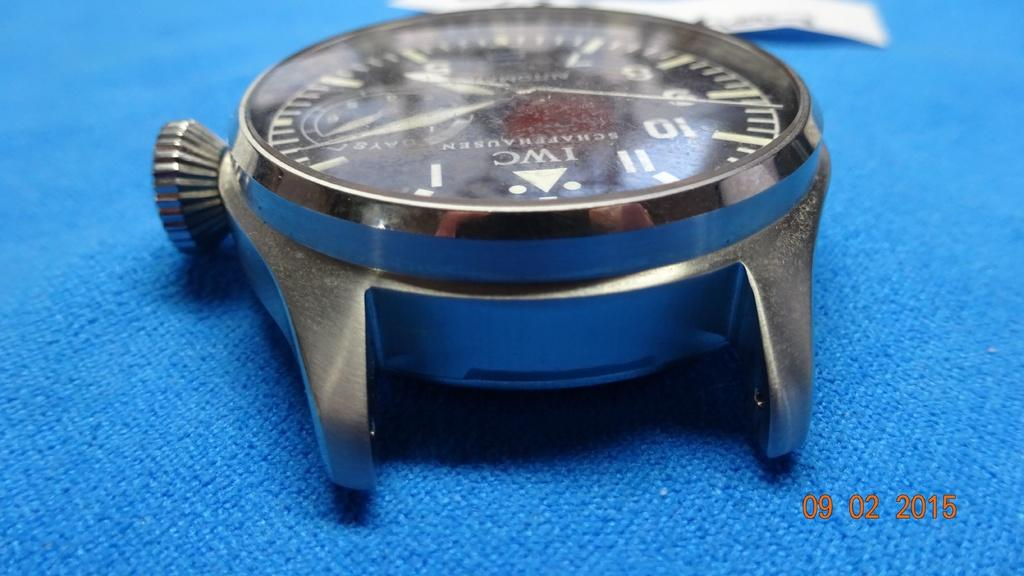<image>
Give a short and clear explanation of the subsequent image. the numbers 1 thru 12 that are on a watch 